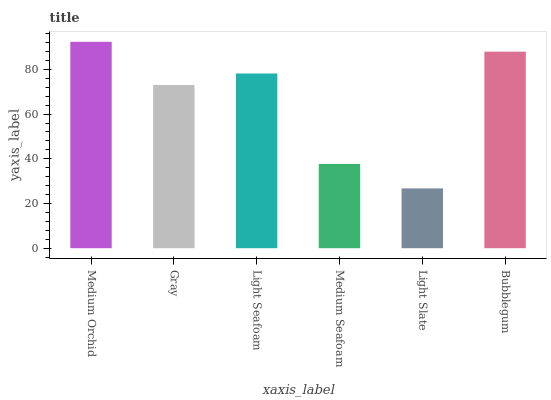Is Light Slate the minimum?
Answer yes or no. Yes. Is Medium Orchid the maximum?
Answer yes or no. Yes. Is Gray the minimum?
Answer yes or no. No. Is Gray the maximum?
Answer yes or no. No. Is Medium Orchid greater than Gray?
Answer yes or no. Yes. Is Gray less than Medium Orchid?
Answer yes or no. Yes. Is Gray greater than Medium Orchid?
Answer yes or no. No. Is Medium Orchid less than Gray?
Answer yes or no. No. Is Light Seafoam the high median?
Answer yes or no. Yes. Is Gray the low median?
Answer yes or no. Yes. Is Gray the high median?
Answer yes or no. No. Is Medium Orchid the low median?
Answer yes or no. No. 